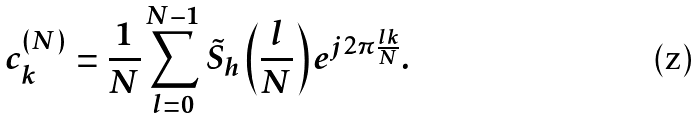<formula> <loc_0><loc_0><loc_500><loc_500>c _ { k } ^ { ( N ) } & = \frac { 1 } { N } \sum _ { l = 0 } ^ { N - 1 } \tilde { S } _ { h } \left ( \frac { l } { N } \right ) e ^ { j 2 \pi \frac { l k } { N } } .</formula> 